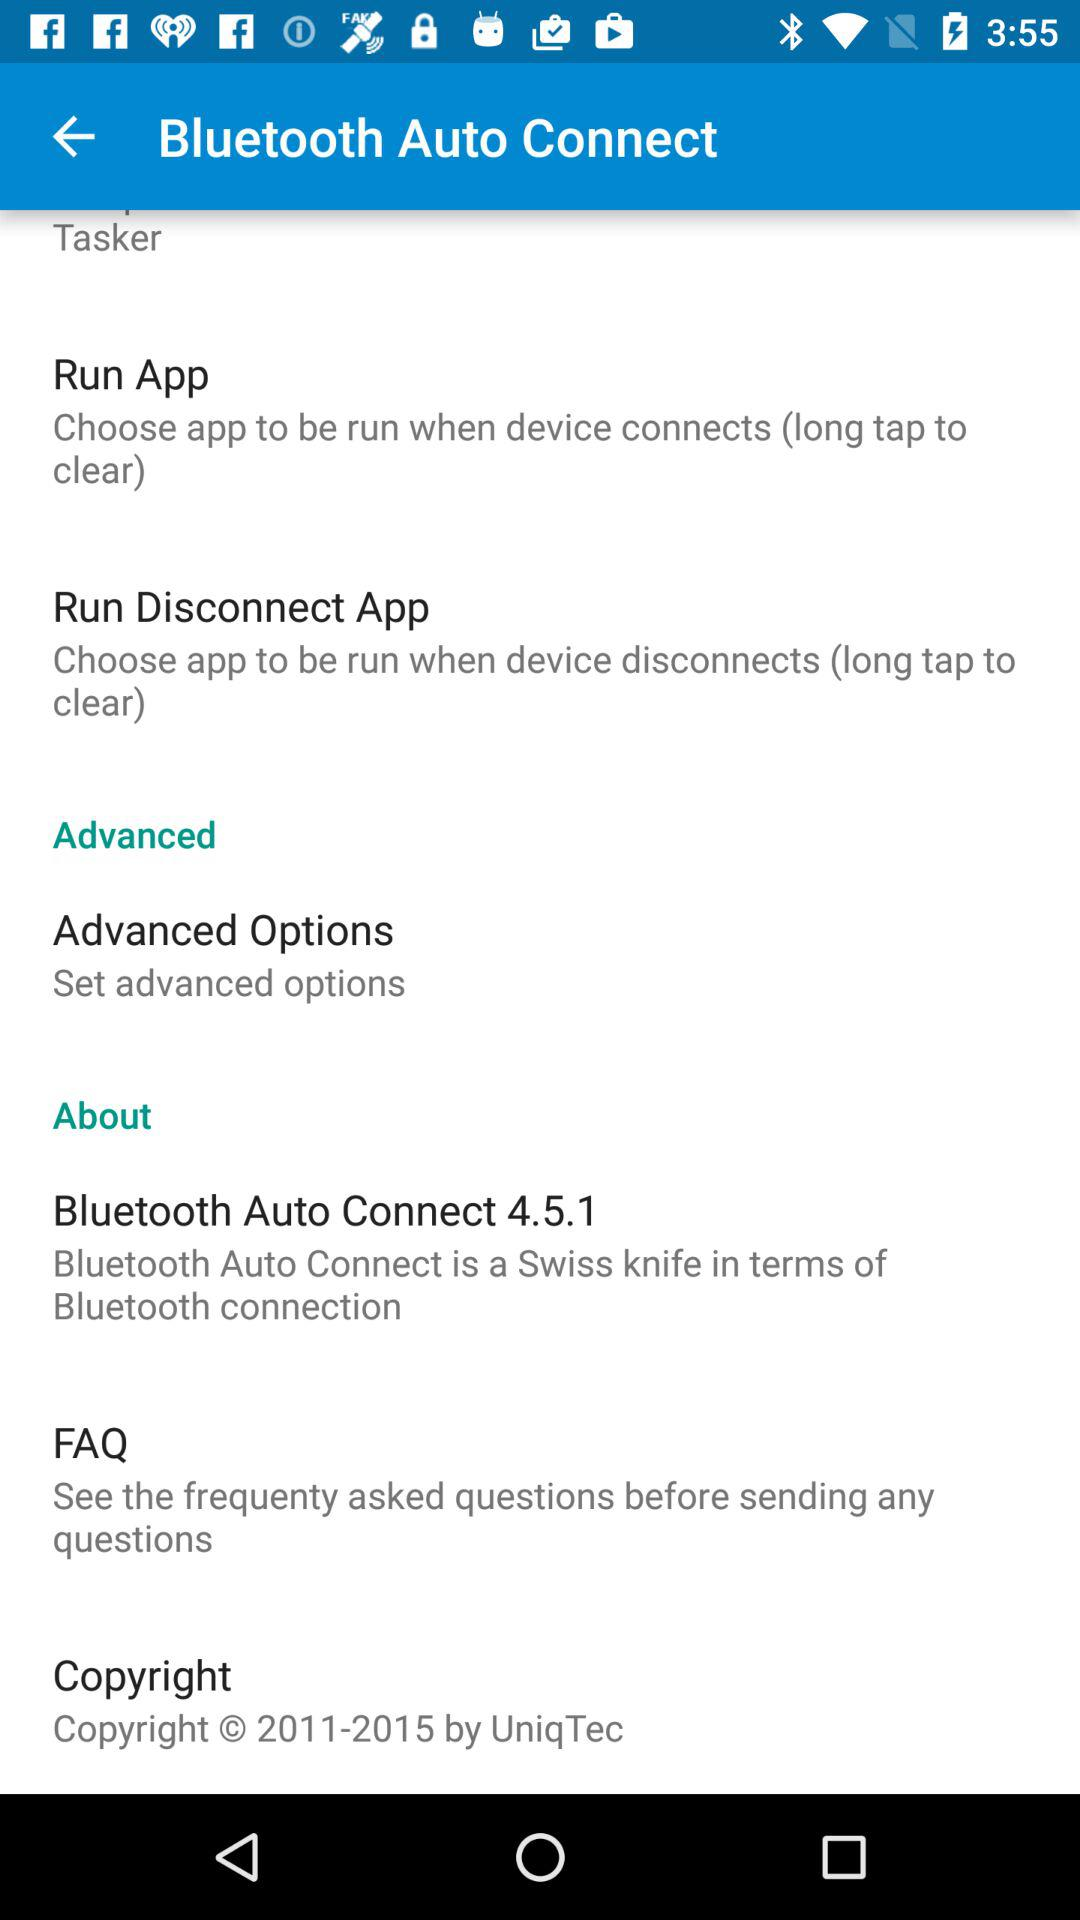What's the version of "Bluetooth Auto Connect"? The version is 4.5.1. 